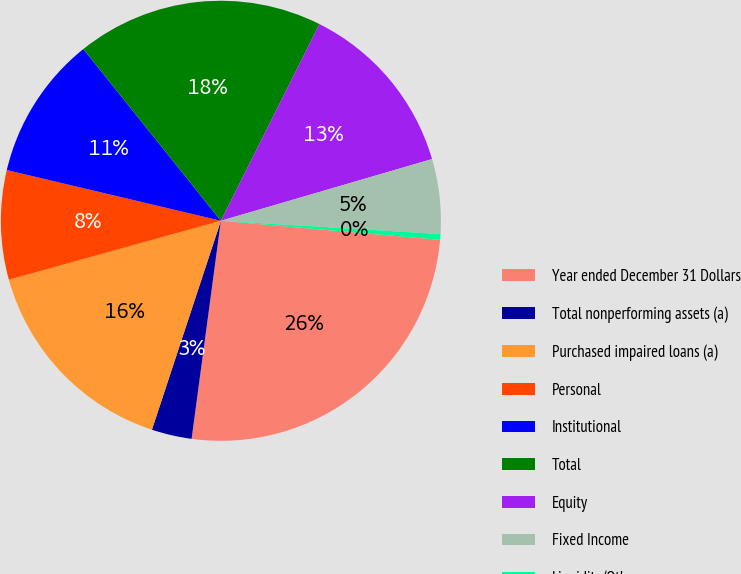Convert chart to OTSL. <chart><loc_0><loc_0><loc_500><loc_500><pie_chart><fcel>Year ended December 31 Dollars<fcel>Total nonperforming assets (a)<fcel>Purchased impaired loans (a)<fcel>Personal<fcel>Institutional<fcel>Total<fcel>Equity<fcel>Fixed Income<fcel>Liquidity/Other<nl><fcel>25.74%<fcel>2.95%<fcel>15.61%<fcel>8.02%<fcel>10.55%<fcel>18.14%<fcel>13.08%<fcel>5.49%<fcel>0.42%<nl></chart> 